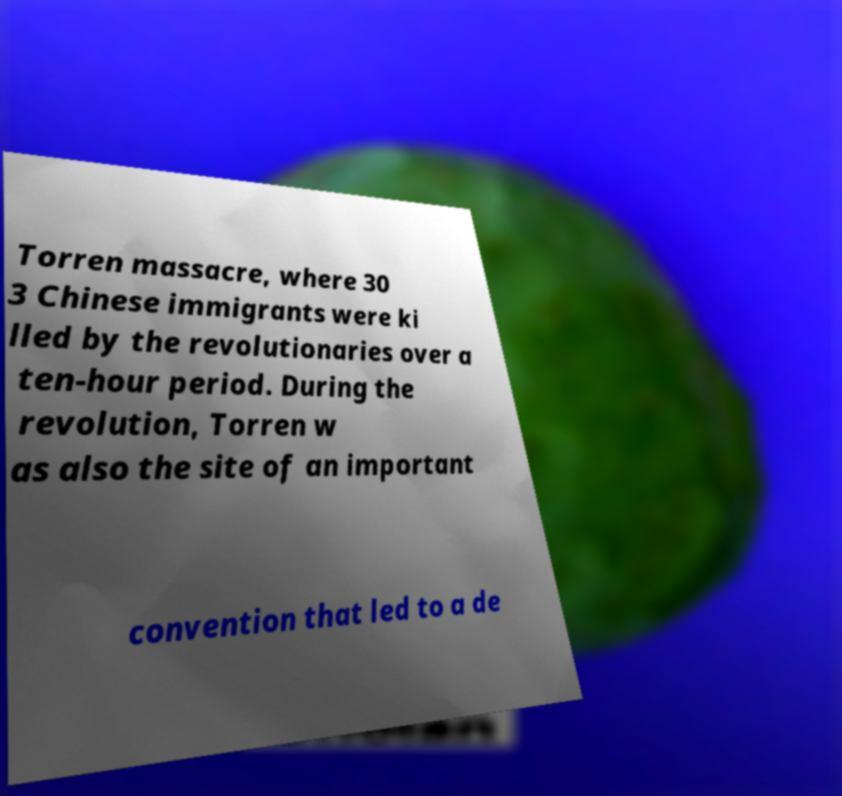What messages or text are displayed in this image? I need them in a readable, typed format. Torren massacre, where 30 3 Chinese immigrants were ki lled by the revolutionaries over a ten-hour period. During the revolution, Torren w as also the site of an important convention that led to a de 